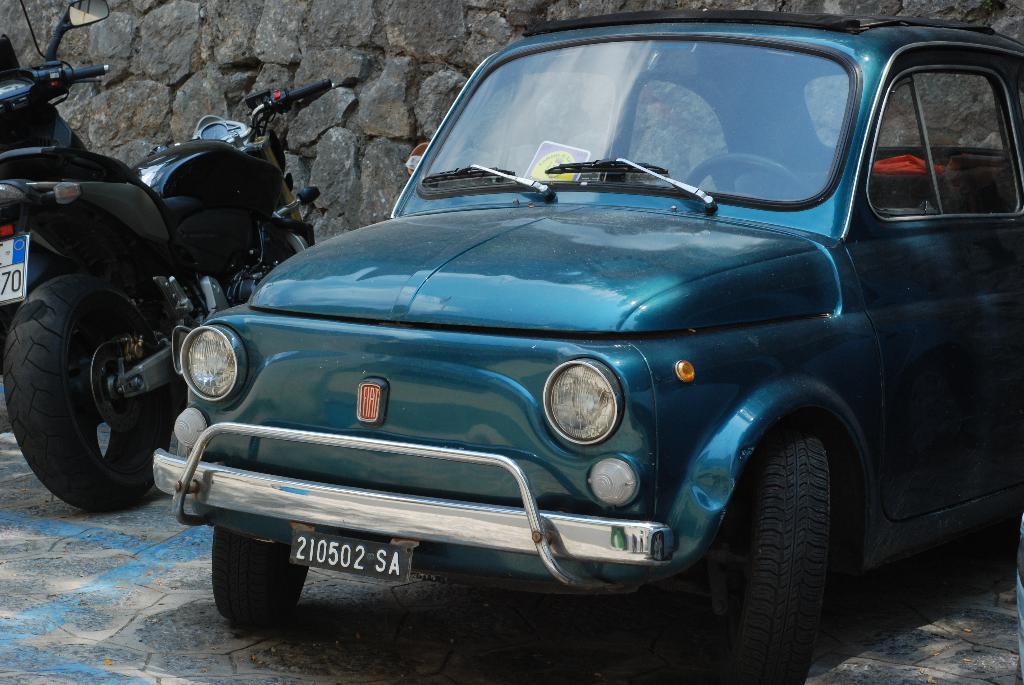Can you describe this image briefly? This image is taken outdoors. In the background there is a wall. At the bottom of the image there is a floor. On the left side of the image two bikes are parked on the floor. On the right side of the image a car is parked on the floor. 